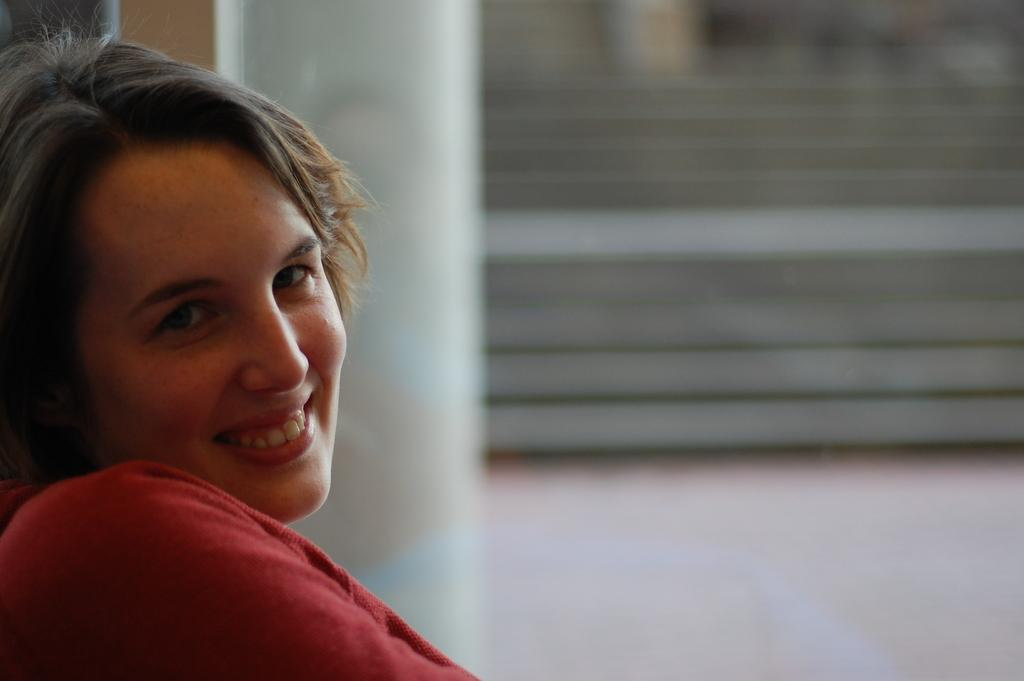Who is present in the image? There is a lady in the image. What is the lady doing in the image? The lady is smiling in the image. What can be seen in the background of the image? There are stairs in the background of the image. How many babies are visible in the image? There are no babies present in the image. What type of needle is being used by the lady in the image? There is no needle present in the image. 